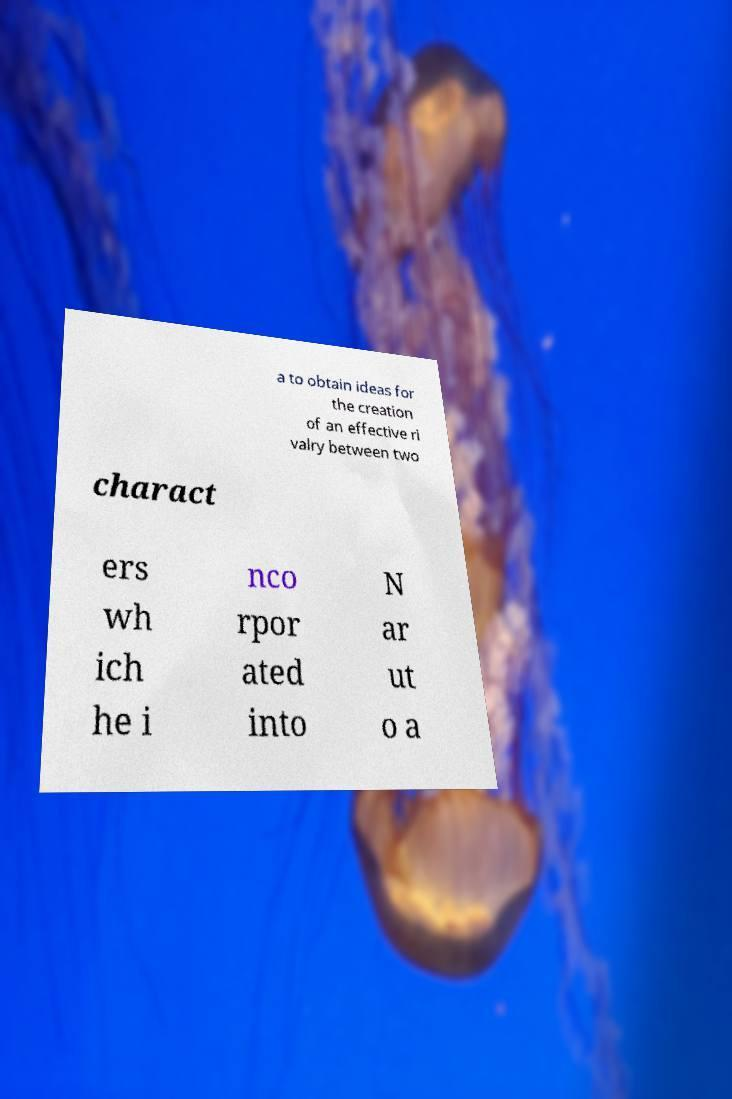For documentation purposes, I need the text within this image transcribed. Could you provide that? a to obtain ideas for the creation of an effective ri valry between two charact ers wh ich he i nco rpor ated into N ar ut o a 